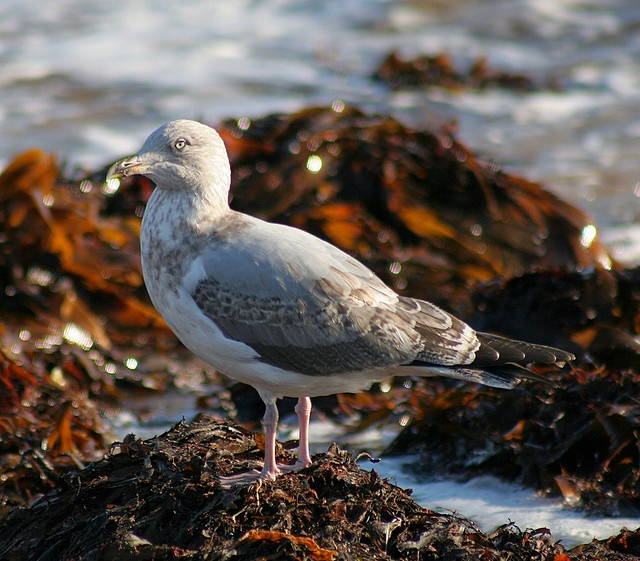Describe the objects in this image and their specific colors. I can see a bird in darkgray, gray, black, and ivory tones in this image. 